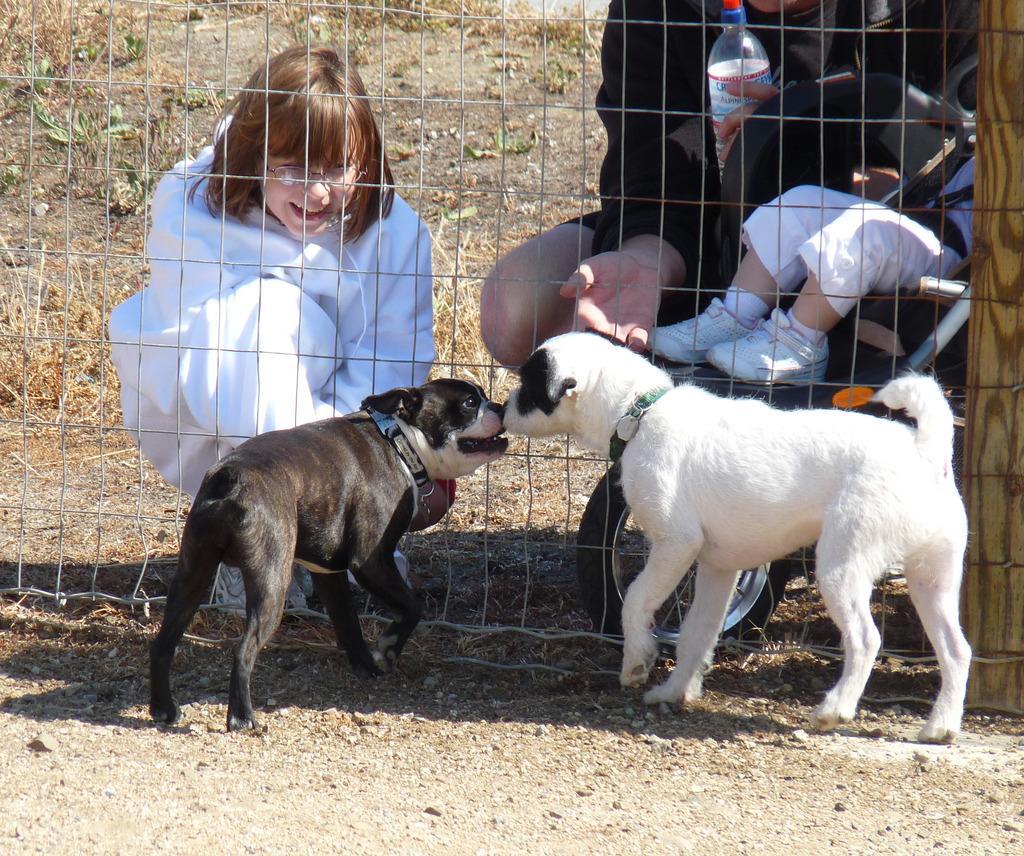In one or two sentences, can you explain what this image depicts? As we can see in the image there are two dogs, two people, a child and a fence. 